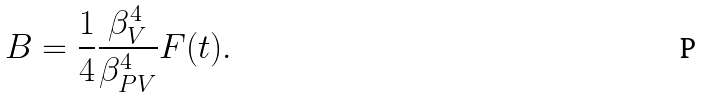Convert formula to latex. <formula><loc_0><loc_0><loc_500><loc_500>B = \frac { 1 } { 4 } \frac { \beta ^ { 4 } _ { V } } { \beta ^ { 4 } _ { P V } } F ( t ) .</formula> 